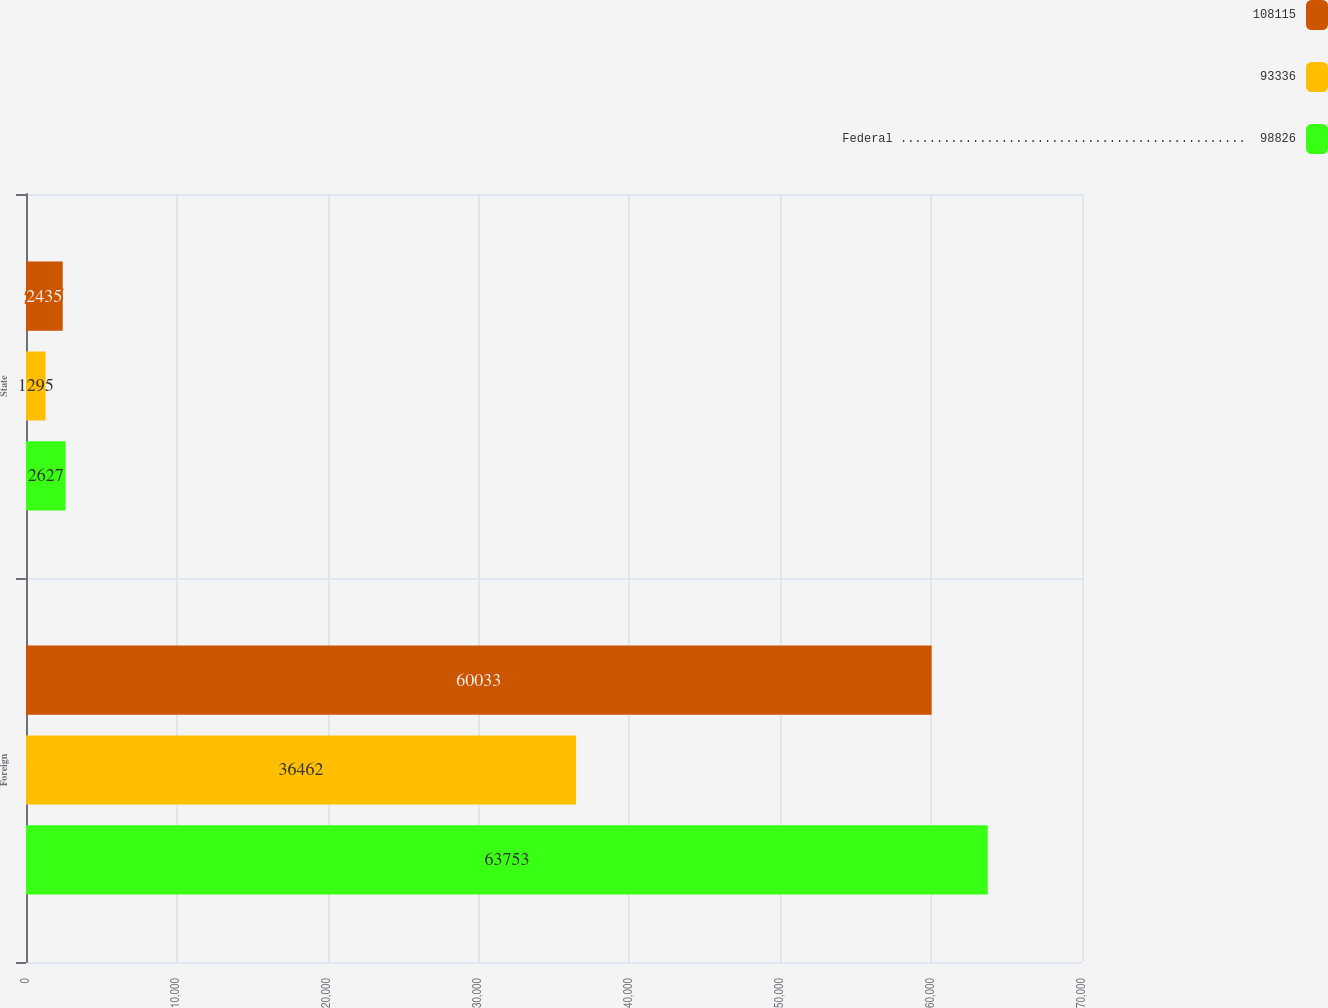<chart> <loc_0><loc_0><loc_500><loc_500><stacked_bar_chart><ecel><fcel>Foreign<fcel>State<nl><fcel>108115<fcel>60033<fcel>2435<nl><fcel>93336<fcel>36462<fcel>1295<nl><fcel>Federal ................................................  98826<fcel>63753<fcel>2627<nl></chart> 